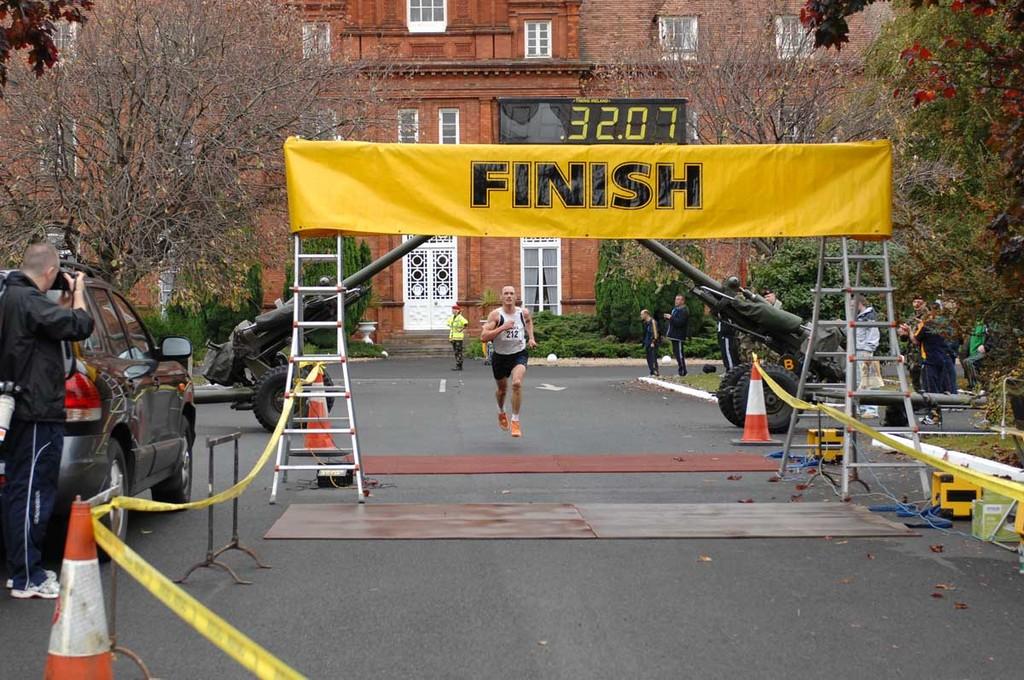Where is the runner about to cross?
Offer a very short reply. Finish. What number is above the finish line?
Your answer should be very brief. 32.07. 